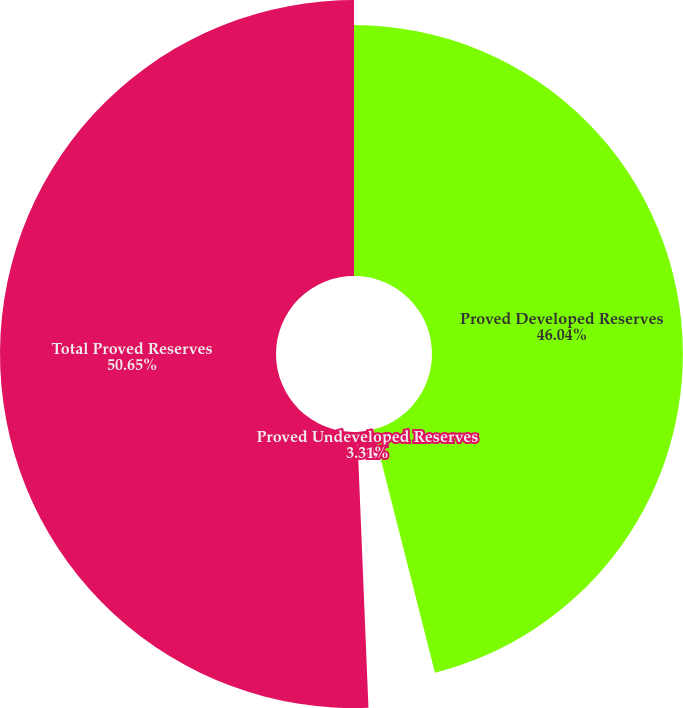Convert chart. <chart><loc_0><loc_0><loc_500><loc_500><pie_chart><fcel>Proved Developed Reserves<fcel>Proved Undeveloped Reserves<fcel>Total Proved Reserves<nl><fcel>46.04%<fcel>3.31%<fcel>50.65%<nl></chart> 